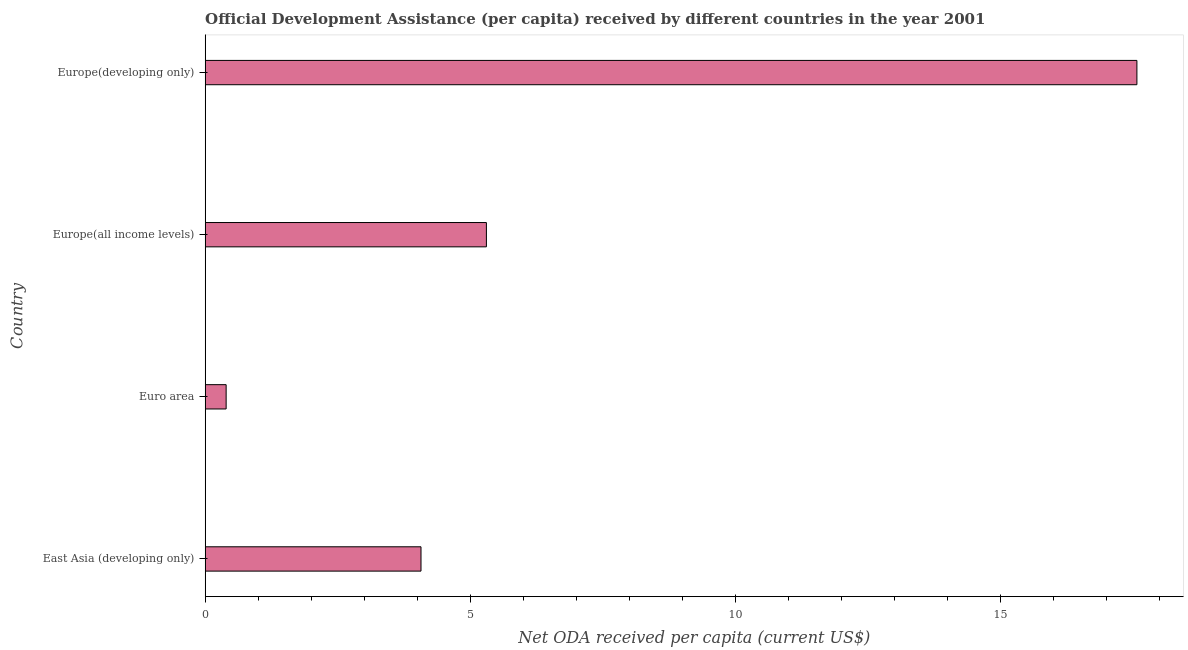What is the title of the graph?
Ensure brevity in your answer.  Official Development Assistance (per capita) received by different countries in the year 2001. What is the label or title of the X-axis?
Your answer should be very brief. Net ODA received per capita (current US$). What is the label or title of the Y-axis?
Make the answer very short. Country. What is the net oda received per capita in Europe(developing only)?
Provide a succinct answer. 17.57. Across all countries, what is the maximum net oda received per capita?
Provide a short and direct response. 17.57. Across all countries, what is the minimum net oda received per capita?
Your answer should be compact. 0.39. In which country was the net oda received per capita maximum?
Give a very brief answer. Europe(developing only). What is the sum of the net oda received per capita?
Your answer should be very brief. 27.33. What is the difference between the net oda received per capita in East Asia (developing only) and Euro area?
Make the answer very short. 3.67. What is the average net oda received per capita per country?
Provide a short and direct response. 6.83. What is the median net oda received per capita?
Provide a short and direct response. 4.69. What is the ratio of the net oda received per capita in Europe(all income levels) to that in Europe(developing only)?
Your answer should be compact. 0.3. What is the difference between the highest and the second highest net oda received per capita?
Your answer should be very brief. 12.26. What is the difference between the highest and the lowest net oda received per capita?
Offer a very short reply. 17.17. In how many countries, is the net oda received per capita greater than the average net oda received per capita taken over all countries?
Provide a succinct answer. 1. How many bars are there?
Give a very brief answer. 4. How many countries are there in the graph?
Offer a very short reply. 4. Are the values on the major ticks of X-axis written in scientific E-notation?
Make the answer very short. No. What is the Net ODA received per capita (current US$) in East Asia (developing only)?
Provide a short and direct response. 4.07. What is the Net ODA received per capita (current US$) in Euro area?
Your answer should be very brief. 0.39. What is the Net ODA received per capita (current US$) in Europe(all income levels)?
Your answer should be compact. 5.3. What is the Net ODA received per capita (current US$) of Europe(developing only)?
Offer a very short reply. 17.57. What is the difference between the Net ODA received per capita (current US$) in East Asia (developing only) and Euro area?
Make the answer very short. 3.67. What is the difference between the Net ODA received per capita (current US$) in East Asia (developing only) and Europe(all income levels)?
Offer a very short reply. -1.23. What is the difference between the Net ODA received per capita (current US$) in East Asia (developing only) and Europe(developing only)?
Keep it short and to the point. -13.5. What is the difference between the Net ODA received per capita (current US$) in Euro area and Europe(all income levels)?
Keep it short and to the point. -4.91. What is the difference between the Net ODA received per capita (current US$) in Euro area and Europe(developing only)?
Give a very brief answer. -17.17. What is the difference between the Net ODA received per capita (current US$) in Europe(all income levels) and Europe(developing only)?
Provide a succinct answer. -12.26. What is the ratio of the Net ODA received per capita (current US$) in East Asia (developing only) to that in Euro area?
Your answer should be very brief. 10.3. What is the ratio of the Net ODA received per capita (current US$) in East Asia (developing only) to that in Europe(all income levels)?
Your response must be concise. 0.77. What is the ratio of the Net ODA received per capita (current US$) in East Asia (developing only) to that in Europe(developing only)?
Your response must be concise. 0.23. What is the ratio of the Net ODA received per capita (current US$) in Euro area to that in Europe(all income levels)?
Offer a very short reply. 0.07. What is the ratio of the Net ODA received per capita (current US$) in Euro area to that in Europe(developing only)?
Provide a short and direct response. 0.02. What is the ratio of the Net ODA received per capita (current US$) in Europe(all income levels) to that in Europe(developing only)?
Keep it short and to the point. 0.3. 